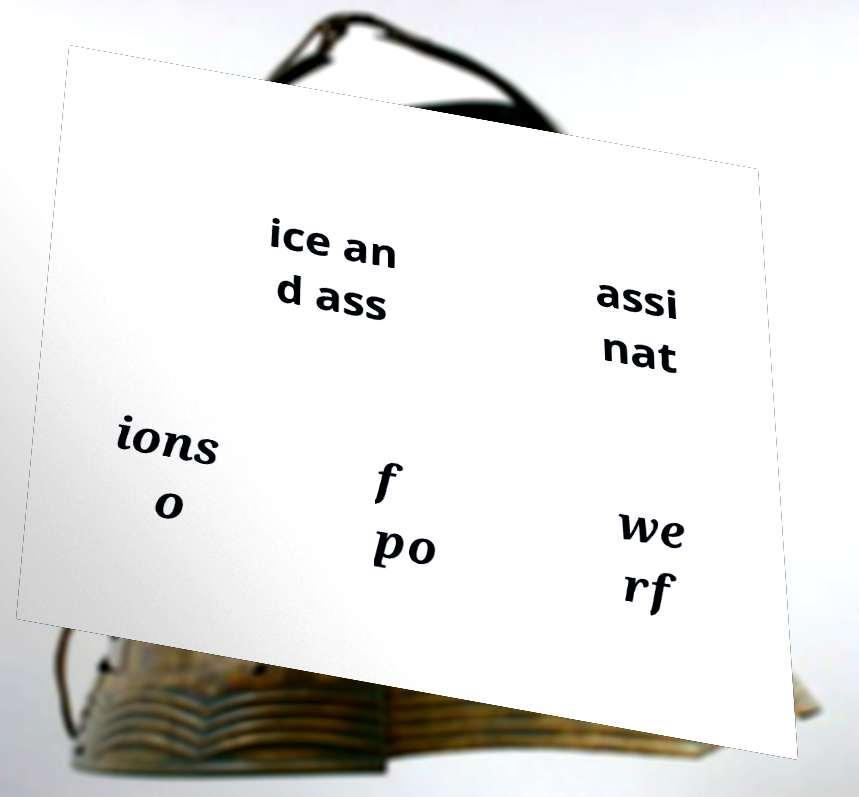Please identify and transcribe the text found in this image. ice an d ass assi nat ions o f po we rf 